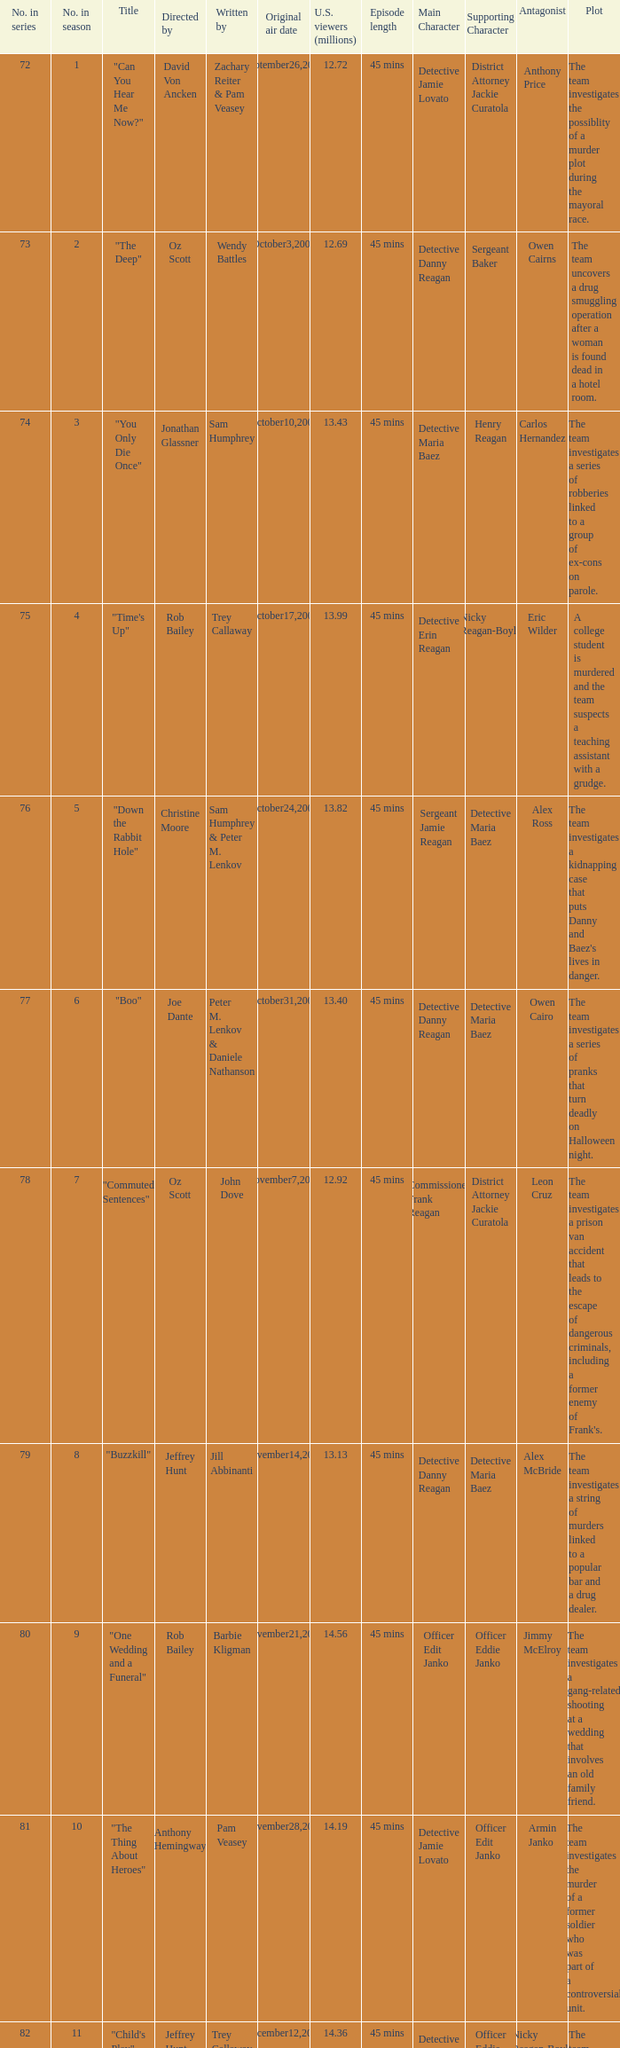Help me parse the entirety of this table. {'header': ['No. in series', 'No. in season', 'Title', 'Directed by', 'Written by', 'Original air date', 'U.S. viewers (millions)', 'Episode length', 'Main Character', 'Supporting Character', 'Antagonist', 'Plot'], 'rows': [['72', '1', '"Can You Hear Me Now?"', 'David Von Ancken', 'Zachary Reiter & Pam Veasey', 'September26,2007', '12.72', '45 mins', 'Detective Jamie Lovato', 'District Attorney Jackie Curatola', 'Anthony Price', 'The team investigates the possiblity of a murder plot during the mayoral race.'], ['73', '2', '"The Deep"', 'Oz Scott', 'Wendy Battles', 'October3,2007', '12.69', '45 mins', 'Detective Danny Reagan', 'Sergeant Baker', 'Owen Cairns', 'The team uncovers a drug smuggling operation after a woman is found dead in a hotel room.'], ['74', '3', '"You Only Die Once"', 'Jonathan Glassner', 'Sam Humphrey', 'October10,2007', '13.43', '45 mins', 'Detective Maria Baez', 'Henry Reagan', 'Carlos Hernandez', 'The team investigates a series of robberies linked to a group of ex-cons on parole.'], ['75', '4', '"Time\'s Up"', 'Rob Bailey', 'Trey Callaway', 'October17,2007', '13.99', '45 mins', 'Detective Erin Reagan', 'Nicky Reagan-Boyle', 'Eric Wilder', 'A college student is murdered and the team suspects a teaching assistant with a grudge.'], ['76', '5', '"Down the Rabbit Hole"', 'Christine Moore', 'Sam Humphrey & Peter M. Lenkov', 'October24,2007', '13.82', '45 mins', 'Sergeant Jamie Reagan', 'Detective Maria Baez', 'Alex Ross', "The team investigates a kidnapping case that puts Danny and Baez's lives in danger."], ['77', '6', '"Boo"', 'Joe Dante', 'Peter M. Lenkov & Daniele Nathanson', 'October31,2007', '13.40', '45 mins', 'Detective Danny Reagan', 'Detective Maria Baez', 'Owen Cairo', 'The team investigates a series of pranks that turn deadly on Halloween night.'], ['78', '7', '"Commuted Sentences"', 'Oz Scott', 'John Dove', 'November7,2007', '12.92', '45 mins', 'Commissioner Frank Reagan', 'District Attorney Jackie Curatola', 'Leon Cruz', "The team investigates a prison van accident that leads to the escape of dangerous criminals, including a former enemy of Frank's."], ['79', '8', '"Buzzkill"', 'Jeffrey Hunt', 'Jill Abbinanti', 'November14,2007', '13.13', '45 mins', 'Detective Danny Reagan', 'Detective Maria Baez', 'Alex McBride', 'The team investigates a string of murders linked to a popular bar and a drug dealer.'], ['80', '9', '"One Wedding and a Funeral"', 'Rob Bailey', 'Barbie Kligman', 'November21,2007', '14.56', '45 mins', 'Officer Edit Janko', 'Officer Eddie Janko', 'Jimmy McElroy', 'The team investigates a gang-related shooting at a wedding that involves an old family friend.'], ['81', '10', '"The Thing About Heroes"', 'Anthony Hemingway', 'Pam Veasey', 'November28,2007', '14.19', '45 mins', 'Detective Jamie Lovato', 'Officer Edit Janko', 'Armin Janko', 'The team investigates the murder of a former soldier who was part of a controversial unit.'], ['82', '11', '"Child\'s Play"', 'Jeffrey Hunt', 'Trey Callaway & Pam Veasey', 'December12,2007', '14.36', '45 mins', 'Detective Maria Baez', 'Officer Eddie Janko', 'Nicky Reagan-Boyle', 'The team investigates the murder of a toy company executive and uncovers a feud between the victim and her siblings.'], ['83', '12', '"Happily Never After"', 'Marshall Adams', 'Daniele Nathanson & Noah Nelson', 'January9,2008', '11.71', '45 mins', 'Detective Danny Reagan', 'Detective Maria Baez', 'Eddie Marquez', 'The team investigates the murder of a bride-to-be and discovers a connection to a series of unsolved homicides.'], ['84', '13', '"All in the Family"', 'Rob Bailey', 'Wendy Battles', 'January23,2008', '11.51', '45 mins', 'Commissioner Frank Reagan', 'Detective Danny Reagan', 'Katherine Tucker', "Frank's neighbor is arrested for possession and the team uncovers a larger drug operation with ties to the neighborhood."], ['85', '14', '"Playing With Matches"', 'Christine Moore', 'Bill Haynes', 'February6,2008', '10.16', '45 mins', 'Detective Maria Baez', 'Officer Eddie Janko', 'Gary Heller', 'The team investigates a fire at a local boxing gym and discovers a connection to organized crime.'], ['86', '15', '"DOA For a Day"', 'Christine Moore', 'Peter M. Lenkov & John Dove', 'April2,2008', '12.85', '45 mins', 'Detective Erin Reagan', 'Detective Anthony Abetemarco', 'Johnny Tesla', "The team investigates a murder at a popular tourist spot and uncovers a conspiracy within the victim's own family."], ['87', '16', '"Right Next Door"', 'Rob Bailey', 'Pam Veasey', 'April9,2008', '12.38', '45 mins', 'Detective Danny Reagan', 'Detective Maria Baez', 'Trent Bowden', "The team investigates a murder in a wealthy suburban neighborhood and uncovers a dark secret about the victim's family."], ['88', '17', '"Like Water For Murder"', 'Anthony Hemingway', 'Sam Humphrey', 'April16,2008', '13.43', '45 mins', 'Officer Edit Janko', 'Officer Eddie Janko', 'Andy Powell', 'The team investigates a murder at a high-end spa and uncovers a web of lies and secret relationships among its staff.'], ['89', '18', '"Admissions"', 'Rob Bailey', 'Zachary Reiter', 'April30,2008', '11.51', '45 mins', 'Detective Jamie Lovato', 'Sergeant Gormley', 'Malcolm Cleary', 'The team investigates a murder at a prestigious private school and uncovers a competition between parents to get their children into elite colleges.'], ['90', '19', '"Personal Foul"', 'David Von Ancken', 'Trey Callaway', 'May7,2008', '12.73', '45 mins', 'Detective Maria Baez', 'Sergeant Jamie Reagan', 'Ed Gormley Jr.', "The team investigates a dirty cop who has ties to Danny's past and may be connected to a series of murders."], ['91', '20', '"Taxi"', 'Christine Moore', 'Barbie Kligman & John Dove', 'May14,2008', '11.86', '45 mins', 'Detective Danny Reagan', 'Detective Maria Baez', 'Freddy Ramirez', 'The team investigates a taxi cab company that may be involved in drug trafficking and the murder of one of its drivers.']]} How many millions of U.S. viewers watched the episode "Buzzkill"?  1.0. 